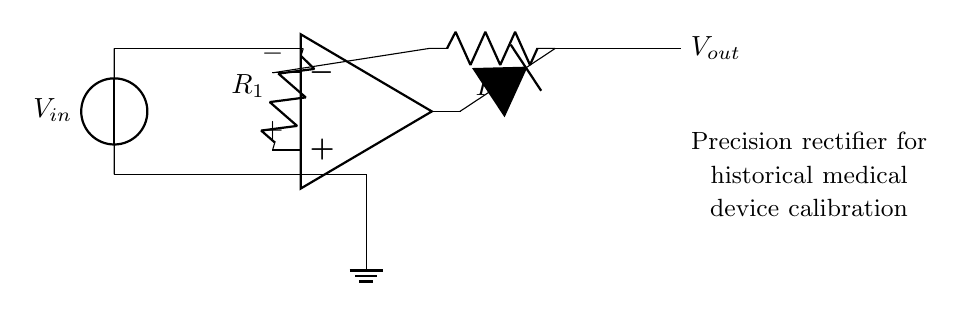What is the main active component in this circuit? The main active component is the operational amplifier, which is responsible for amplifying the input signal and driving the output. It can be identified as the unique component labeled as the op-amp in the circuit diagram.
Answer: operational amplifier What type of rectifier is represented in this circuit? The circuit represents a precision rectifier, which is designed to provide accurate rectification of small signals, especially useful in calibration applications for medical devices. This is indicated by the specific arrangement of the op-amp and diode.
Answer: precision rectifier What is the function of the diode in this circuit? The diode allows current to flow in only one direction, which is essential for rectifying the input voltage. It ensures that negative voltages do not appear in the output, which is necessary for precision measurements in calibration.
Answer: rectify input voltage What is the role of resistor R1? Resistor R1 is used to set the gain of the operational amplifier circuit, influencing how the input voltage is amplified before it is rectified by the diode. This is critical for achieving the desired output level for calibration purposes.
Answer: set gain How does this circuit improve measurement accuracy in historical medical devices? This circuit improves measurement accuracy by allowing for precise rectification of small AC signals, minimizing voltage drop typical in standard diode rectifiers. It enables accurate calibration, crucial for historical devices that may have less robust measurement systems.
Answer: precise rectification What is the output voltage denoted in the circuit? The output voltage is labeled as Vout, which indicates the voltage that is produced after the rectification process and is presented at the output terminal of the circuit.
Answer: Vout 